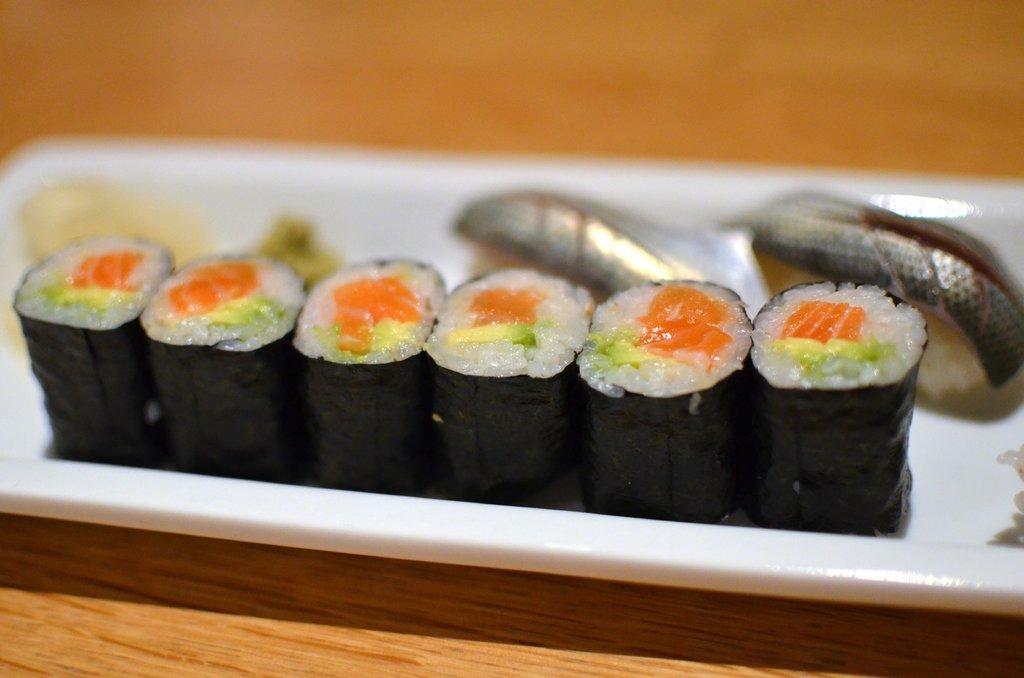Could you give a brief overview of what you see in this image? In this image in the foreground there is a plate and inside this plate there are six black covers. 